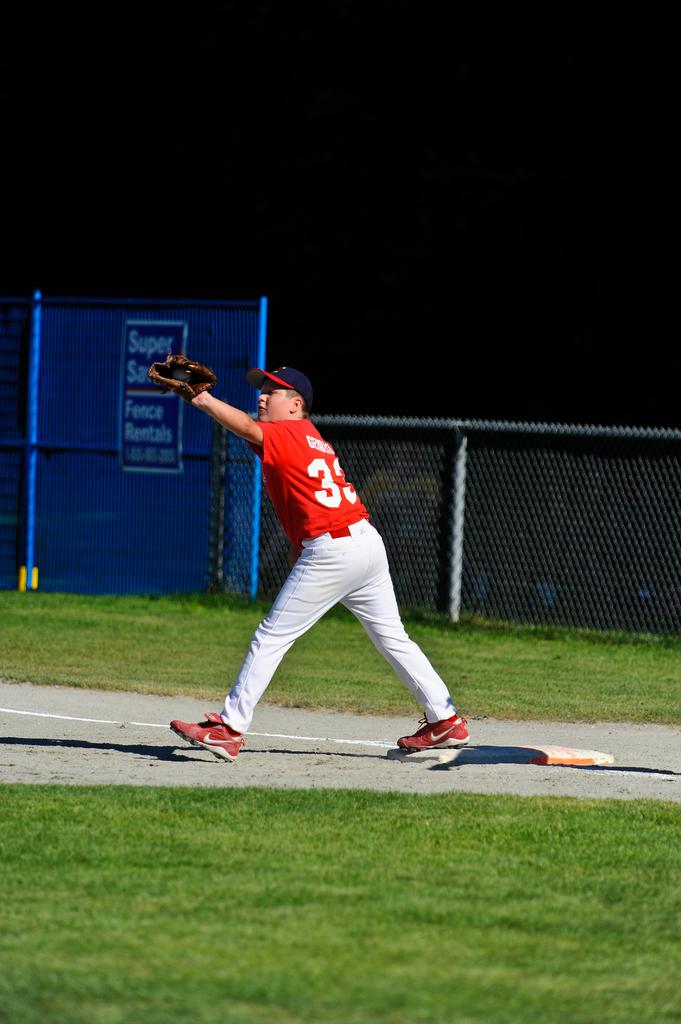What number is the player?
Offer a very short reply. 33. 